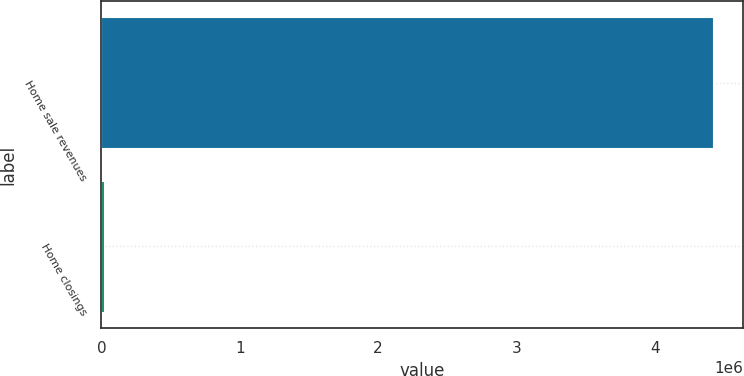Convert chart. <chart><loc_0><loc_0><loc_500><loc_500><bar_chart><fcel>Home sale revenues<fcel>Home closings<nl><fcel>4.41981e+06<fcel>17095<nl></chart> 